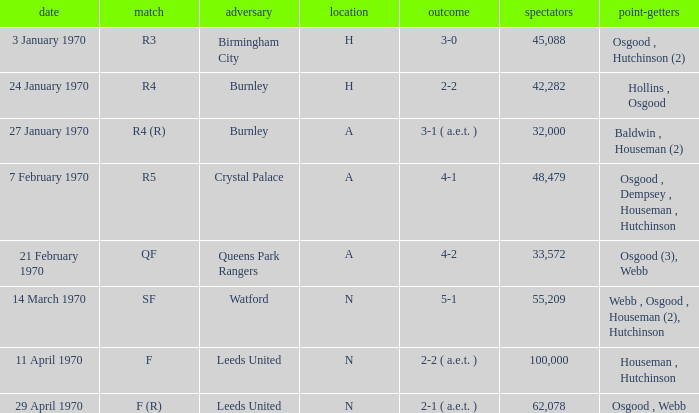What is the maximum attendance at a match with a score of 5-1? 55209.0. 